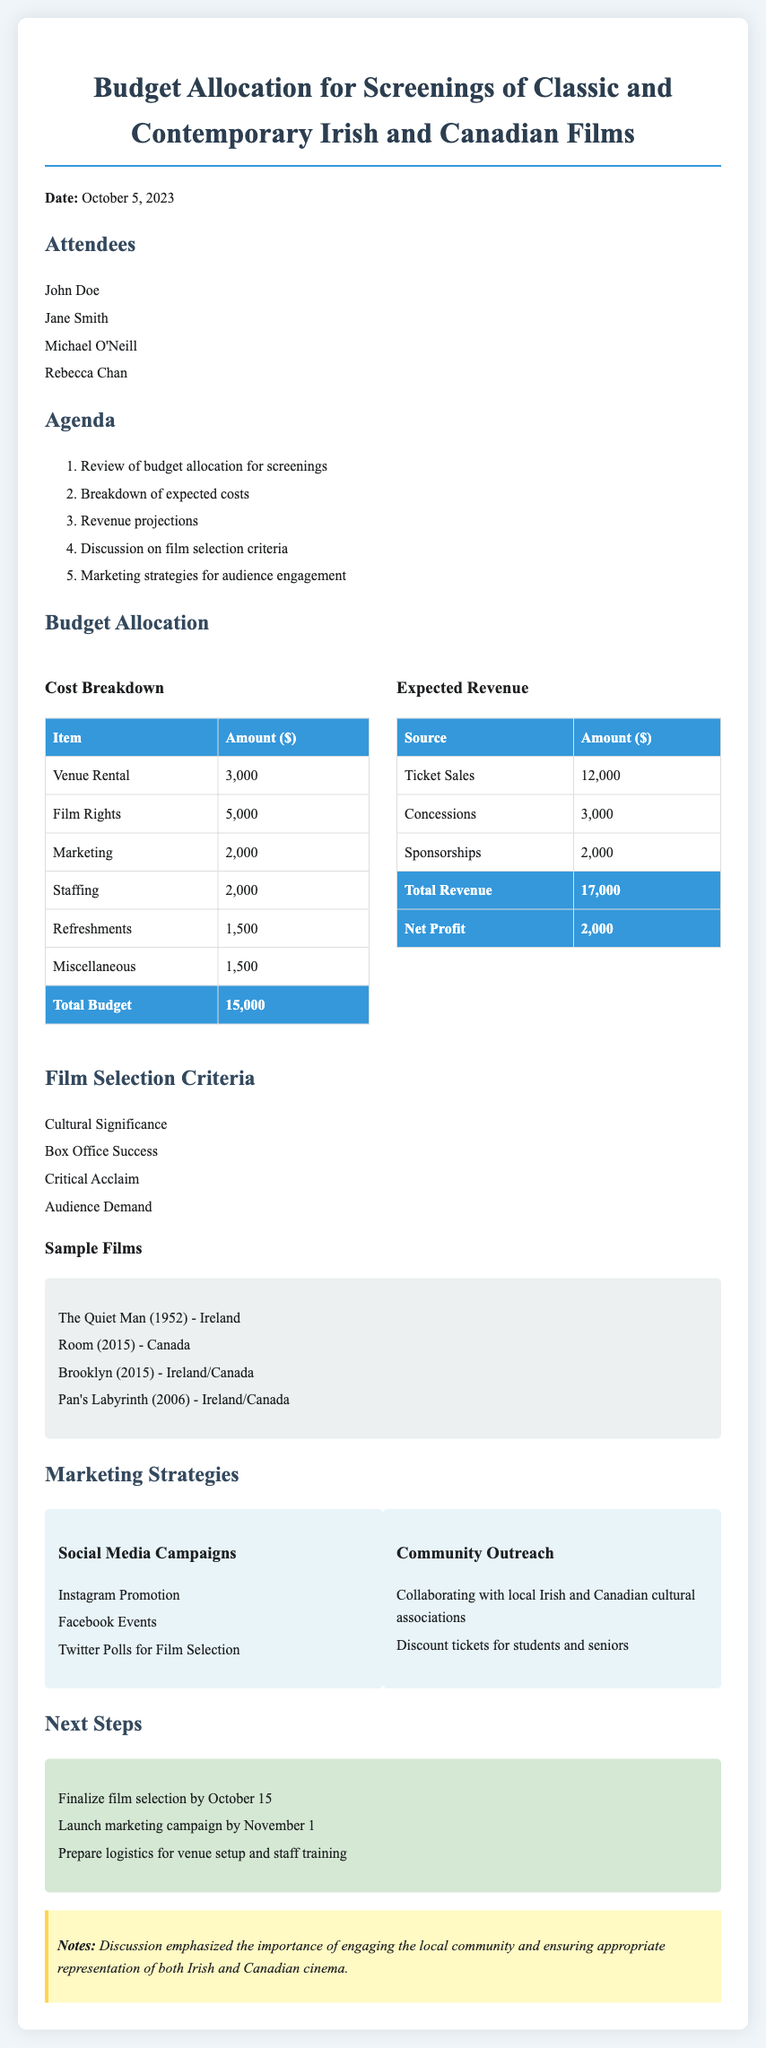what is the date of the meeting? The date of the meeting is provided at the beginning of the document.
Answer: October 5, 2023 who are the attendees listed in the document? The document lists the names of individuals who attended the meeting.
Answer: John Doe, Jane Smith, Michael O'Neill, Rebecca Chan what is the total budget allocated for the screenings? The total budget is found in the cost breakdown section of the document.
Answer: 15,000 how much revenue is expected from ticket sales? The revenue from ticket sales is detailed in the expected revenue section.
Answer: 12,000 what is the net profit according to the document? The net profit is calculated based on total revenue and total costs in the budget section.
Answer: 2,000 which film from the sample list was released in 1952? The sample films include specific titles and their release years.
Answer: The Quiet Man what marketing strategy involves social media? The marketing strategies are listed, and one focuses on social media campaigns.
Answer: Social Media Campaigns when is the deadline to finalize film selection? The next steps section specifies this timeline.
Answer: October 15 what is one criterion for film selection mentioned? The document lists the criteria for film selection, highlighting significant factors.
Answer: Cultural Significance 